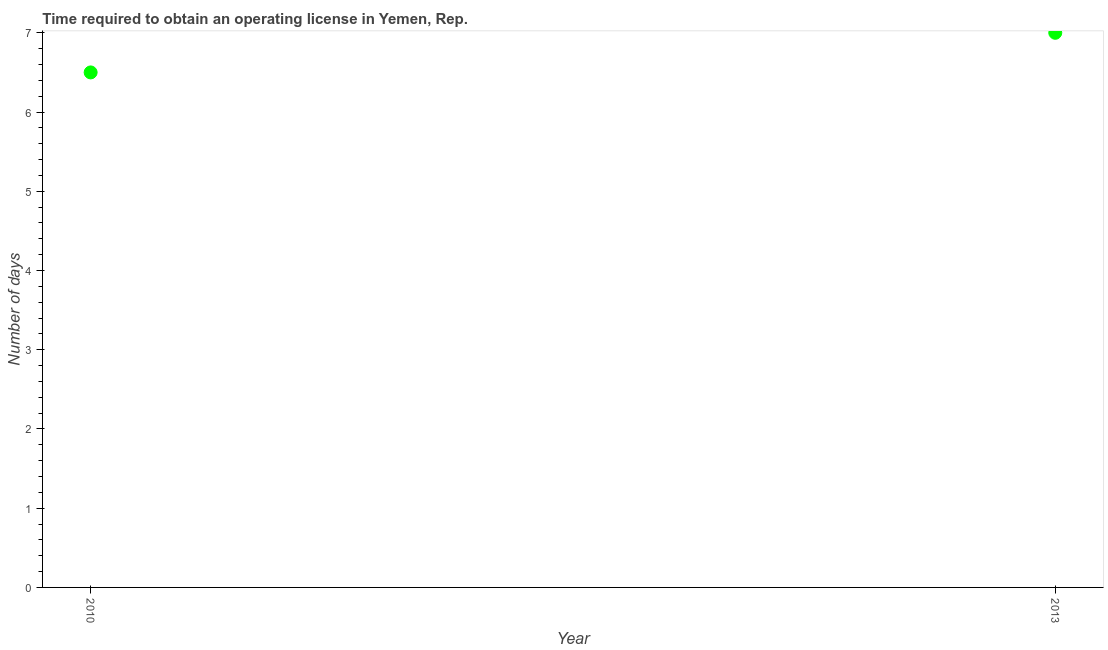Across all years, what is the maximum number of days to obtain operating license?
Your answer should be compact. 7. What is the sum of the number of days to obtain operating license?
Provide a short and direct response. 13.5. What is the difference between the number of days to obtain operating license in 2010 and 2013?
Make the answer very short. -0.5. What is the average number of days to obtain operating license per year?
Give a very brief answer. 6.75. What is the median number of days to obtain operating license?
Offer a terse response. 6.75. What is the ratio of the number of days to obtain operating license in 2010 to that in 2013?
Your answer should be very brief. 0.93. Is the number of days to obtain operating license in 2010 less than that in 2013?
Offer a very short reply. Yes. Are the values on the major ticks of Y-axis written in scientific E-notation?
Provide a short and direct response. No. Does the graph contain any zero values?
Give a very brief answer. No. Does the graph contain grids?
Your answer should be compact. No. What is the title of the graph?
Give a very brief answer. Time required to obtain an operating license in Yemen, Rep. What is the label or title of the X-axis?
Your answer should be very brief. Year. What is the label or title of the Y-axis?
Offer a terse response. Number of days. What is the Number of days in 2013?
Give a very brief answer. 7. What is the difference between the Number of days in 2010 and 2013?
Your answer should be very brief. -0.5. What is the ratio of the Number of days in 2010 to that in 2013?
Keep it short and to the point. 0.93. 